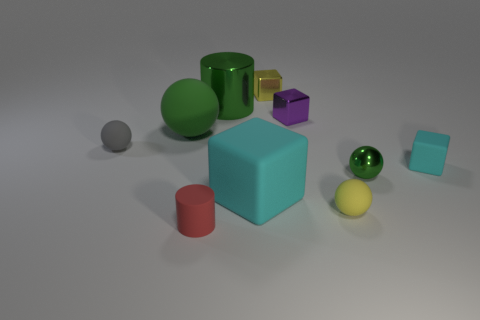There is a yellow ball that is the same size as the gray matte thing; what is its material? The yellow ball appears to be made of a material similar to plastic or rubber, commonly used in such objects to provide smoothness and bounce. 